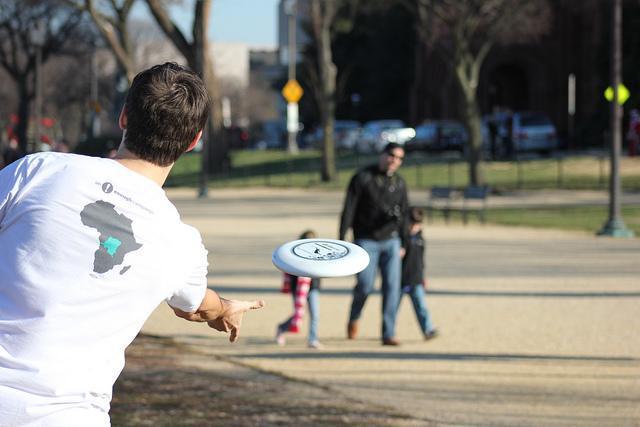How many people are there?
Give a very brief answer. 4. How many frisbees are there?
Give a very brief answer. 1. How many cows are directly facing the camera?
Give a very brief answer. 0. 